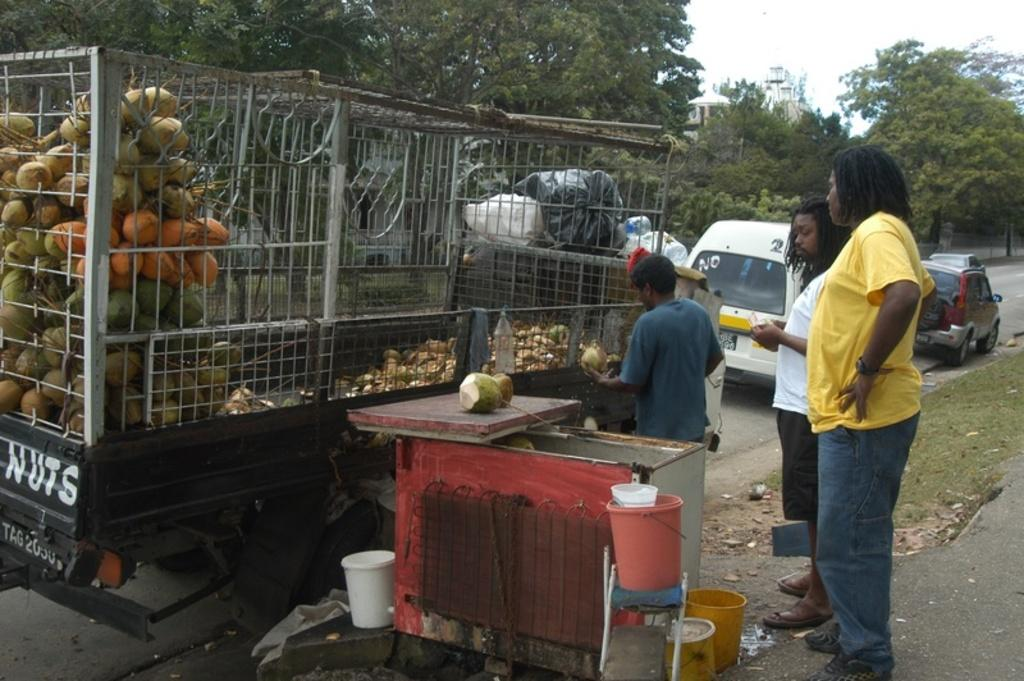How many people are standing in the image? There are three people standing on the ground in the image. What can be seen on the road in the image? There are vehicles on the road in the image. What type of fruit is visible in the image? There are coconuts visible in the image. What objects are present in the scene? There are buckets present in the image. What type of vegetation is visible in the image? Grass is visible in the image. What is visible in the background of the image? There are trees and the sky visible in the background of the image. What type of trousers are the people wearing in the image? There is no information about the type of trousers the people are wearing in the image. What business are the people conducting in the image? There is no indication of any business activity in the image. 